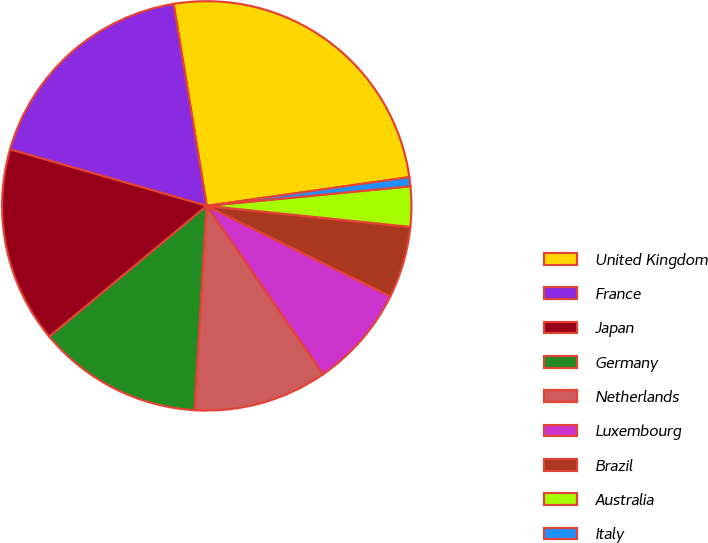Convert chart. <chart><loc_0><loc_0><loc_500><loc_500><pie_chart><fcel>United Kingdom<fcel>France<fcel>Japan<fcel>Germany<fcel>Netherlands<fcel>Luxembourg<fcel>Brazil<fcel>Australia<fcel>Italy<nl><fcel>25.35%<fcel>17.96%<fcel>15.49%<fcel>13.03%<fcel>10.56%<fcel>8.1%<fcel>5.64%<fcel>3.17%<fcel>0.71%<nl></chart> 